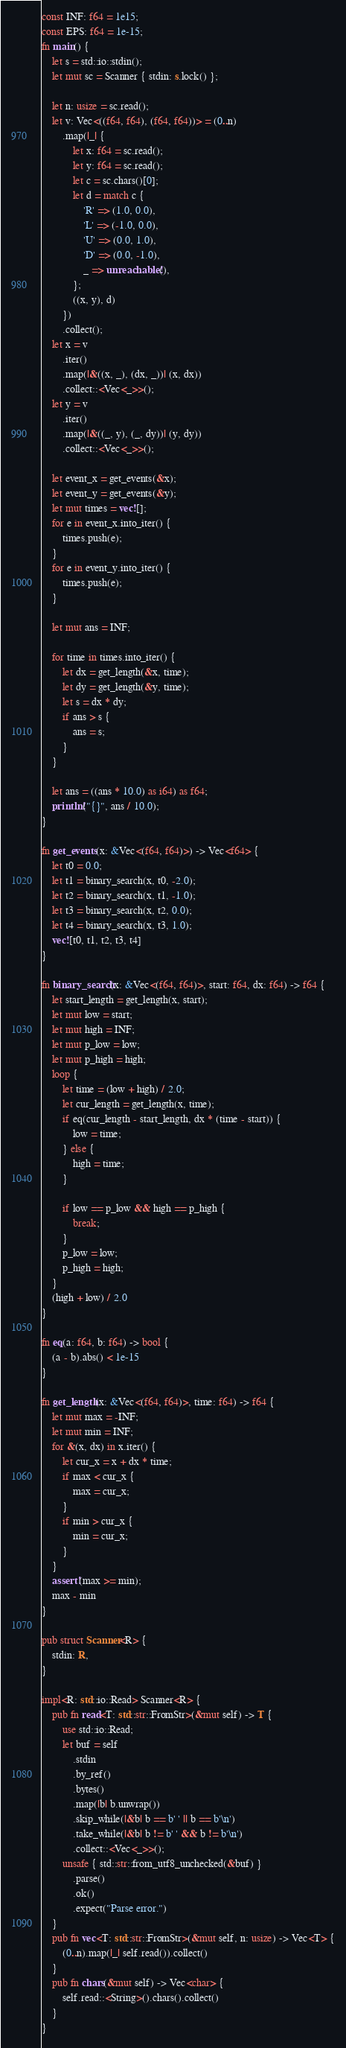Convert code to text. <code><loc_0><loc_0><loc_500><loc_500><_Rust_>const INF: f64 = 1e15;
const EPS: f64 = 1e-15;
fn main() {
    let s = std::io::stdin();
    let mut sc = Scanner { stdin: s.lock() };

    let n: usize = sc.read();
    let v: Vec<((f64, f64), (f64, f64))> = (0..n)
        .map(|_| {
            let x: f64 = sc.read();
            let y: f64 = sc.read();
            let c = sc.chars()[0];
            let d = match c {
                'R' => (1.0, 0.0),
                'L' => (-1.0, 0.0),
                'U' => (0.0, 1.0),
                'D' => (0.0, -1.0),
                _ => unreachable!(),
            };
            ((x, y), d)
        })
        .collect();
    let x = v
        .iter()
        .map(|&((x, _), (dx, _))| (x, dx))
        .collect::<Vec<_>>();
    let y = v
        .iter()
        .map(|&((_, y), (_, dy))| (y, dy))
        .collect::<Vec<_>>();

    let event_x = get_events(&x);
    let event_y = get_events(&y);
    let mut times = vec![];
    for e in event_x.into_iter() {
        times.push(e);
    }
    for e in event_y.into_iter() {
        times.push(e);
    }

    let mut ans = INF;

    for time in times.into_iter() {
        let dx = get_length(&x, time);
        let dy = get_length(&y, time);
        let s = dx * dy;
        if ans > s {
            ans = s;
        }
    }

    let ans = ((ans * 10.0) as i64) as f64;
    println!("{}", ans / 10.0);
}

fn get_events(x: &Vec<(f64, f64)>) -> Vec<f64> {
    let t0 = 0.0;
    let t1 = binary_search(x, t0, -2.0);
    let t2 = binary_search(x, t1, -1.0);
    let t3 = binary_search(x, t2, 0.0);
    let t4 = binary_search(x, t3, 1.0);
    vec![t0, t1, t2, t3, t4]
}

fn binary_search(x: &Vec<(f64, f64)>, start: f64, dx: f64) -> f64 {
    let start_length = get_length(x, start);
    let mut low = start;
    let mut high = INF;
    let mut p_low = low;
    let mut p_high = high;
    loop {
        let time = (low + high) / 2.0;
        let cur_length = get_length(x, time);
        if eq(cur_length - start_length, dx * (time - start)) {
            low = time;
        } else {
            high = time;
        }

        if low == p_low && high == p_high {
            break;
        }
        p_low = low;
        p_high = high;
    }
    (high + low) / 2.0
}

fn eq(a: f64, b: f64) -> bool {
    (a - b).abs() < 1e-15
}

fn get_length(x: &Vec<(f64, f64)>, time: f64) -> f64 {
    let mut max = -INF;
    let mut min = INF;
    for &(x, dx) in x.iter() {
        let cur_x = x + dx * time;
        if max < cur_x {
            max = cur_x;
        }
        if min > cur_x {
            min = cur_x;
        }
    }
    assert!(max >= min);
    max - min
}

pub struct Scanner<R> {
    stdin: R,
}

impl<R: std::io::Read> Scanner<R> {
    pub fn read<T: std::str::FromStr>(&mut self) -> T {
        use std::io::Read;
        let buf = self
            .stdin
            .by_ref()
            .bytes()
            .map(|b| b.unwrap())
            .skip_while(|&b| b == b' ' || b == b'\n')
            .take_while(|&b| b != b' ' && b != b'\n')
            .collect::<Vec<_>>();
        unsafe { std::str::from_utf8_unchecked(&buf) }
            .parse()
            .ok()
            .expect("Parse error.")
    }
    pub fn vec<T: std::str::FromStr>(&mut self, n: usize) -> Vec<T> {
        (0..n).map(|_| self.read()).collect()
    }
    pub fn chars(&mut self) -> Vec<char> {
        self.read::<String>().chars().collect()
    }
}
</code> 